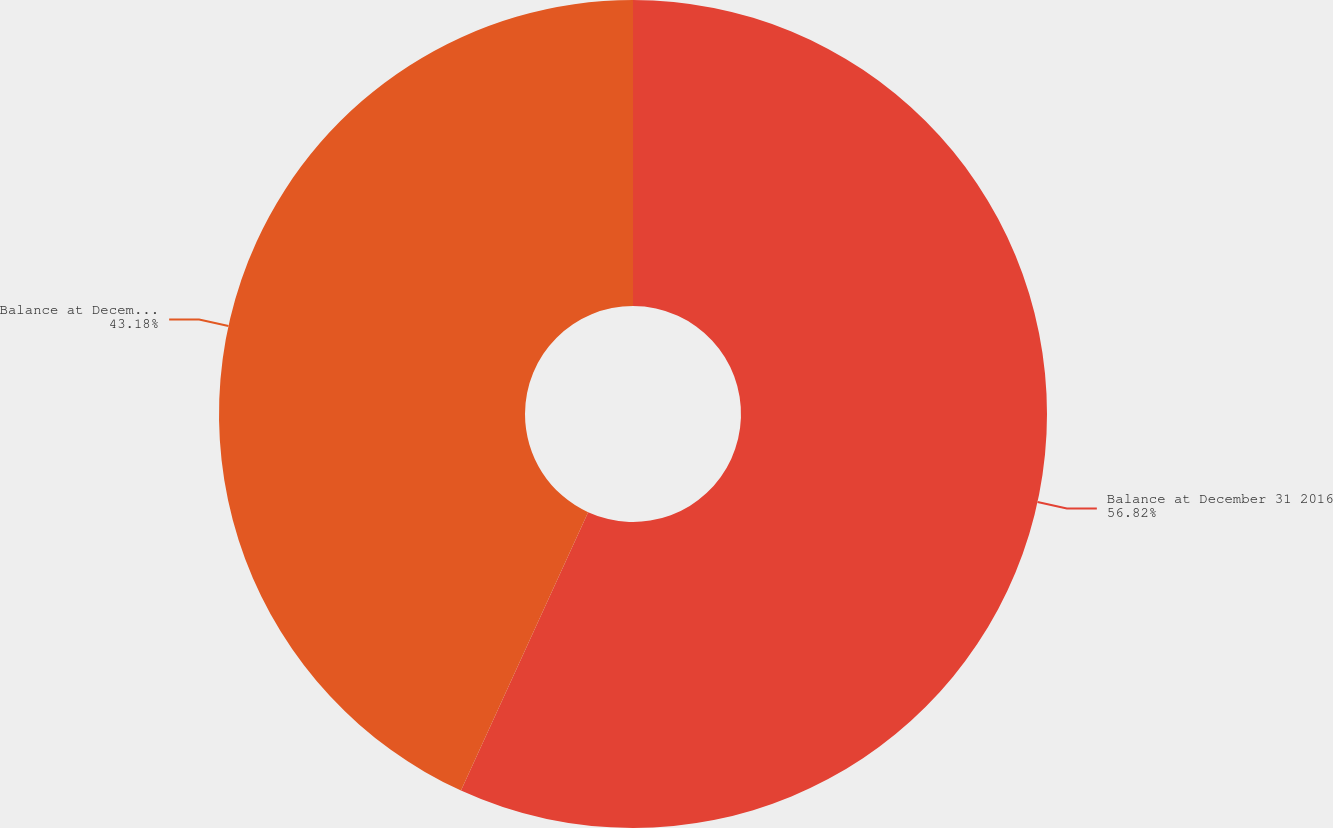Convert chart. <chart><loc_0><loc_0><loc_500><loc_500><pie_chart><fcel>Balance at December 31 2016<fcel>Balance at December 31 2017<nl><fcel>56.82%<fcel>43.18%<nl></chart> 